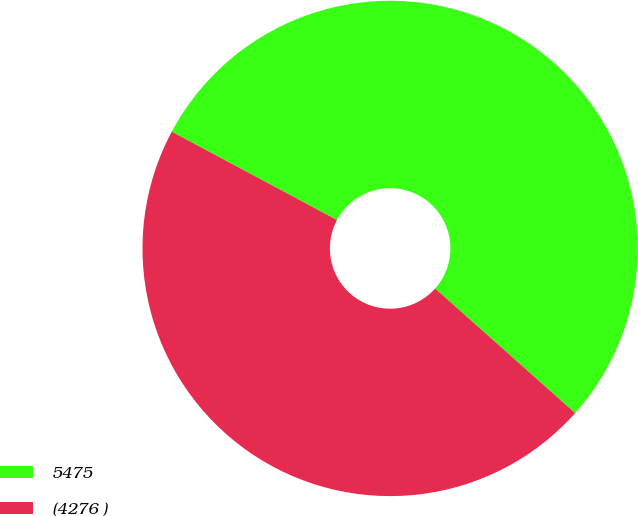Convert chart. <chart><loc_0><loc_0><loc_500><loc_500><pie_chart><fcel>5475<fcel>(4276 )<nl><fcel>53.76%<fcel>46.24%<nl></chart> 